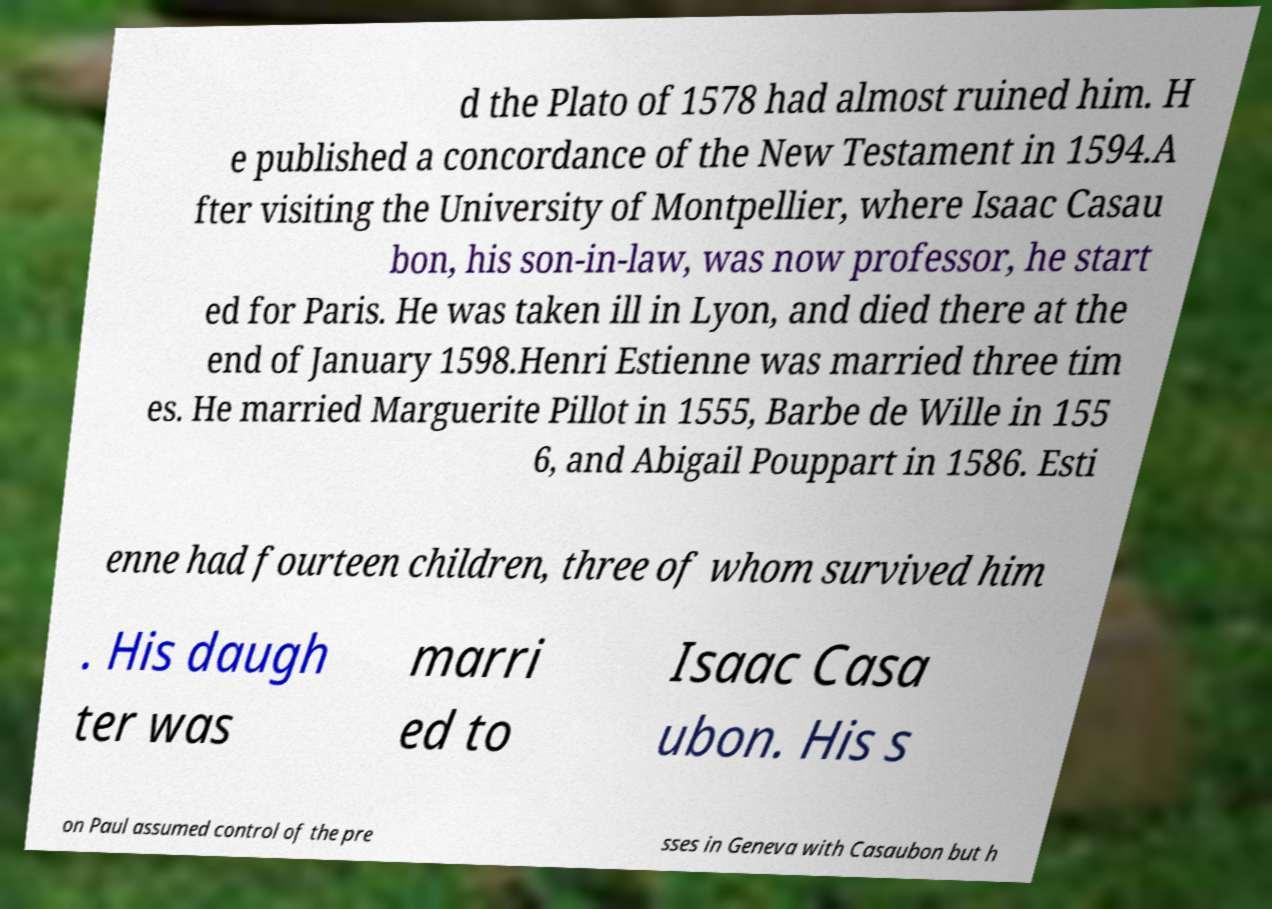Could you extract and type out the text from this image? d the Plato of 1578 had almost ruined him. H e published a concordance of the New Testament in 1594.A fter visiting the University of Montpellier, where Isaac Casau bon, his son-in-law, was now professor, he start ed for Paris. He was taken ill in Lyon, and died there at the end of January 1598.Henri Estienne was married three tim es. He married Marguerite Pillot in 1555, Barbe de Wille in 155 6, and Abigail Pouppart in 1586. Esti enne had fourteen children, three of whom survived him . His daugh ter was marri ed to Isaac Casa ubon. His s on Paul assumed control of the pre sses in Geneva with Casaubon but h 